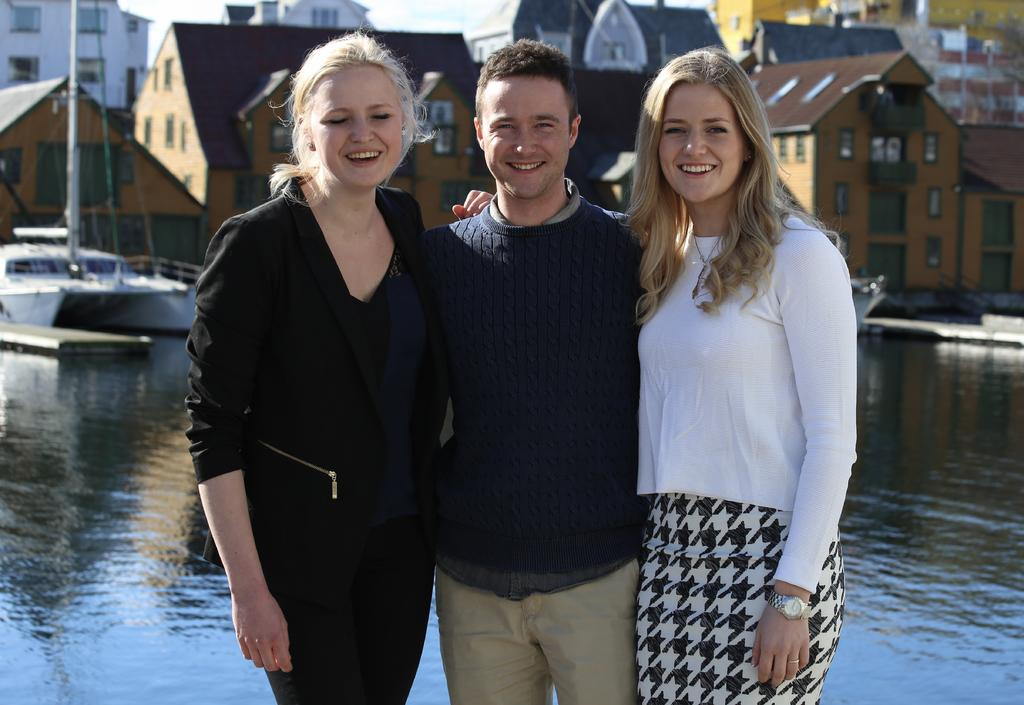How many people can be seen in the image? There are people in the image, but the exact number cannot be determined from the provided facts. What is the primary setting of the image? The image features water, boats with poles, wires, buildings with windows, and the sky, suggesting a waterfront or harbor setting. What can be seen in the sky in the image? The sky is visible in the image, but no specific details about its appearance can be determined from the provided facts. What shape is the ring that the person in the image is wearing? There is no mention of a ring or any jewelry in the image, so it is not possible to answer this question. 